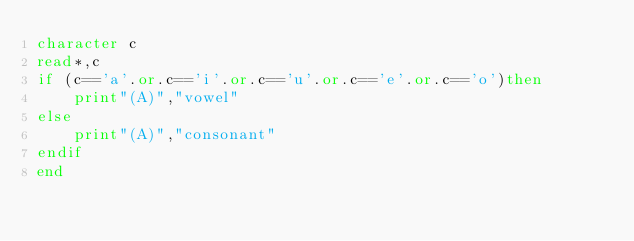Convert code to text. <code><loc_0><loc_0><loc_500><loc_500><_FORTRAN_>character c
read*,c
if (c=='a'.or.c=='i'.or.c=='u'.or.c=='e'.or.c=='o')then
	print"(A)","vowel"
else
	print"(A)","consonant"
endif
end</code> 